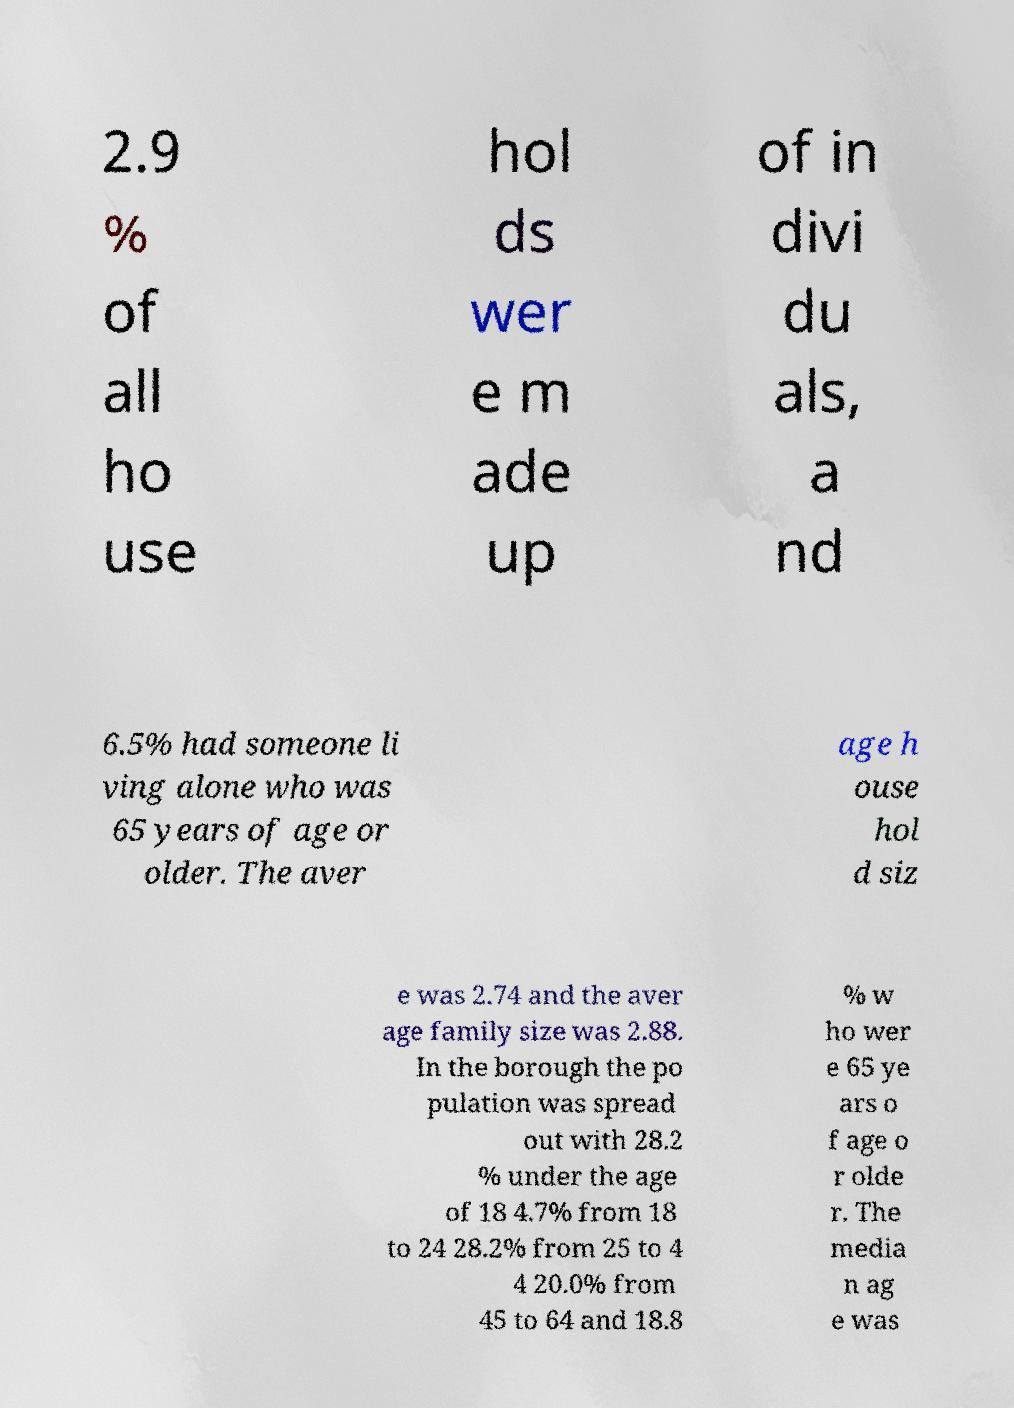Could you extract and type out the text from this image? 2.9 % of all ho use hol ds wer e m ade up of in divi du als, a nd 6.5% had someone li ving alone who was 65 years of age or older. The aver age h ouse hol d siz e was 2.74 and the aver age family size was 2.88. In the borough the po pulation was spread out with 28.2 % under the age of 18 4.7% from 18 to 24 28.2% from 25 to 4 4 20.0% from 45 to 64 and 18.8 % w ho wer e 65 ye ars o f age o r olde r. The media n ag e was 